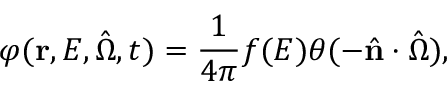Convert formula to latex. <formula><loc_0><loc_0><loc_500><loc_500>\varphi ( r , E , \hat { \Omega } , t ) = \frac { 1 } { 4 \pi } f ( E ) \theta ( - \hat { n } \cdot \hat { \Omega } ) ,</formula> 